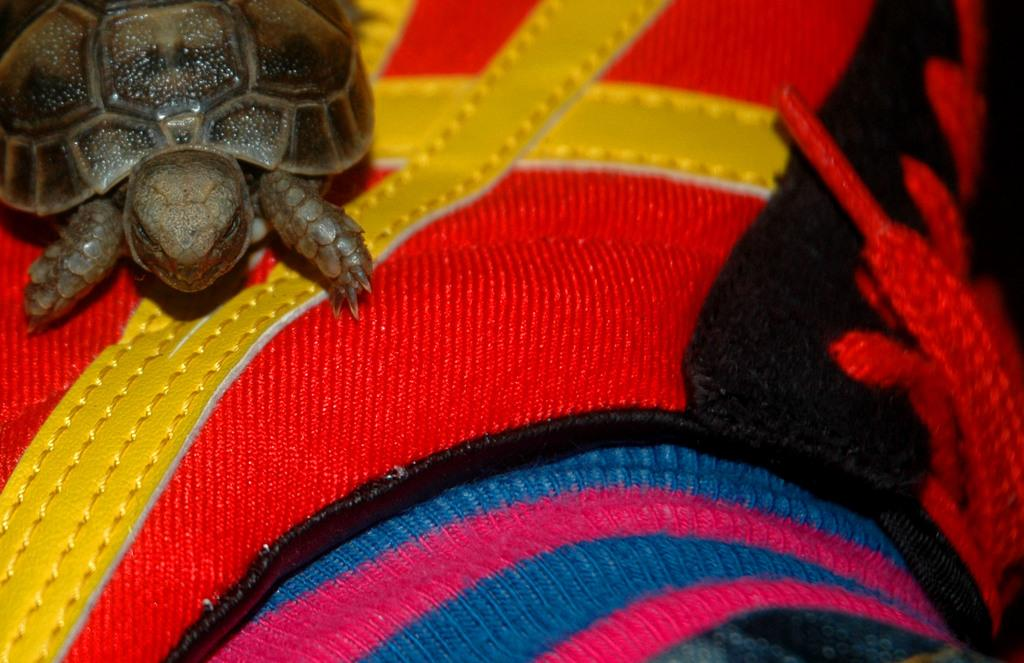What type of animal is in the image? There is a tortoise in the image. What is the tortoise resting on? The tortoise is on a colorful cloth. What type of lace is used to decorate the tortoise's shell in the image? There is no lace present in the image, nor is it mentioned that the tortoise's shell is decorated. 